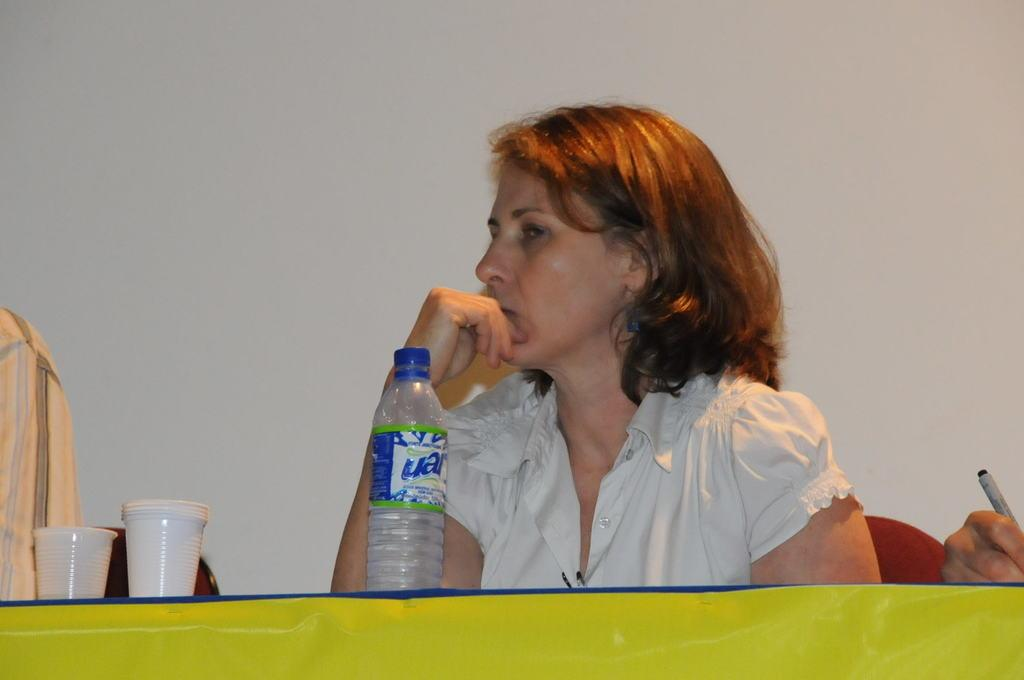Who is the main subject in the image? There is a woman in the image. What is in front of the woman? There is a table in front of the woman. What items can be seen on the table? There are glasses and a bottle on the table. What color is the wall in the background of the image? There is a white color wall in the background of the image. What type of tax is being discussed in the image? There is no discussion of tax in the image; it features a woman, a table, glasses, a bottle, and a white color wall in the background. How many grapes are visible on the table in the image? There are no grapes present on the table in the image. 